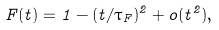<formula> <loc_0><loc_0><loc_500><loc_500>F ( t ) = 1 - ( t / \tau _ { F } ) ^ { 2 } + o ( t ^ { 2 } ) ,</formula> 